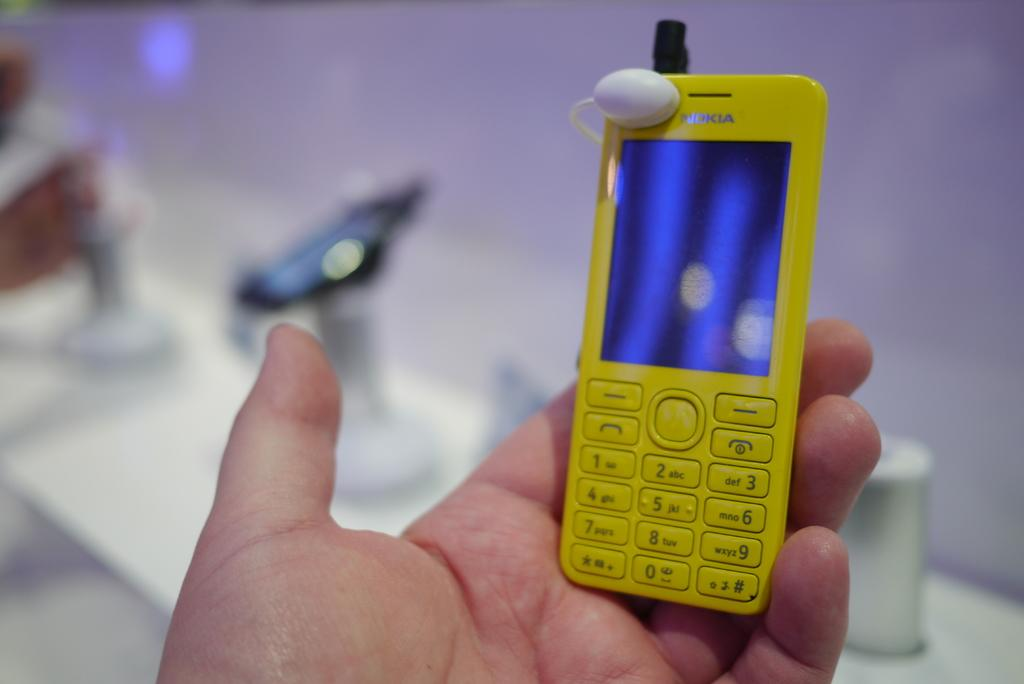What is the person's hand holding in the image? There is a person's hand holding a mobile in the image. How would you describe the background of the image? The background of the image is blurry. Can you identify any objects in the background of the image? Yes, there are objects visible in the background of the image. What book is the person reading in the image? There is no book visible in the image, and the person's hand is holding a mobile, not a book. 